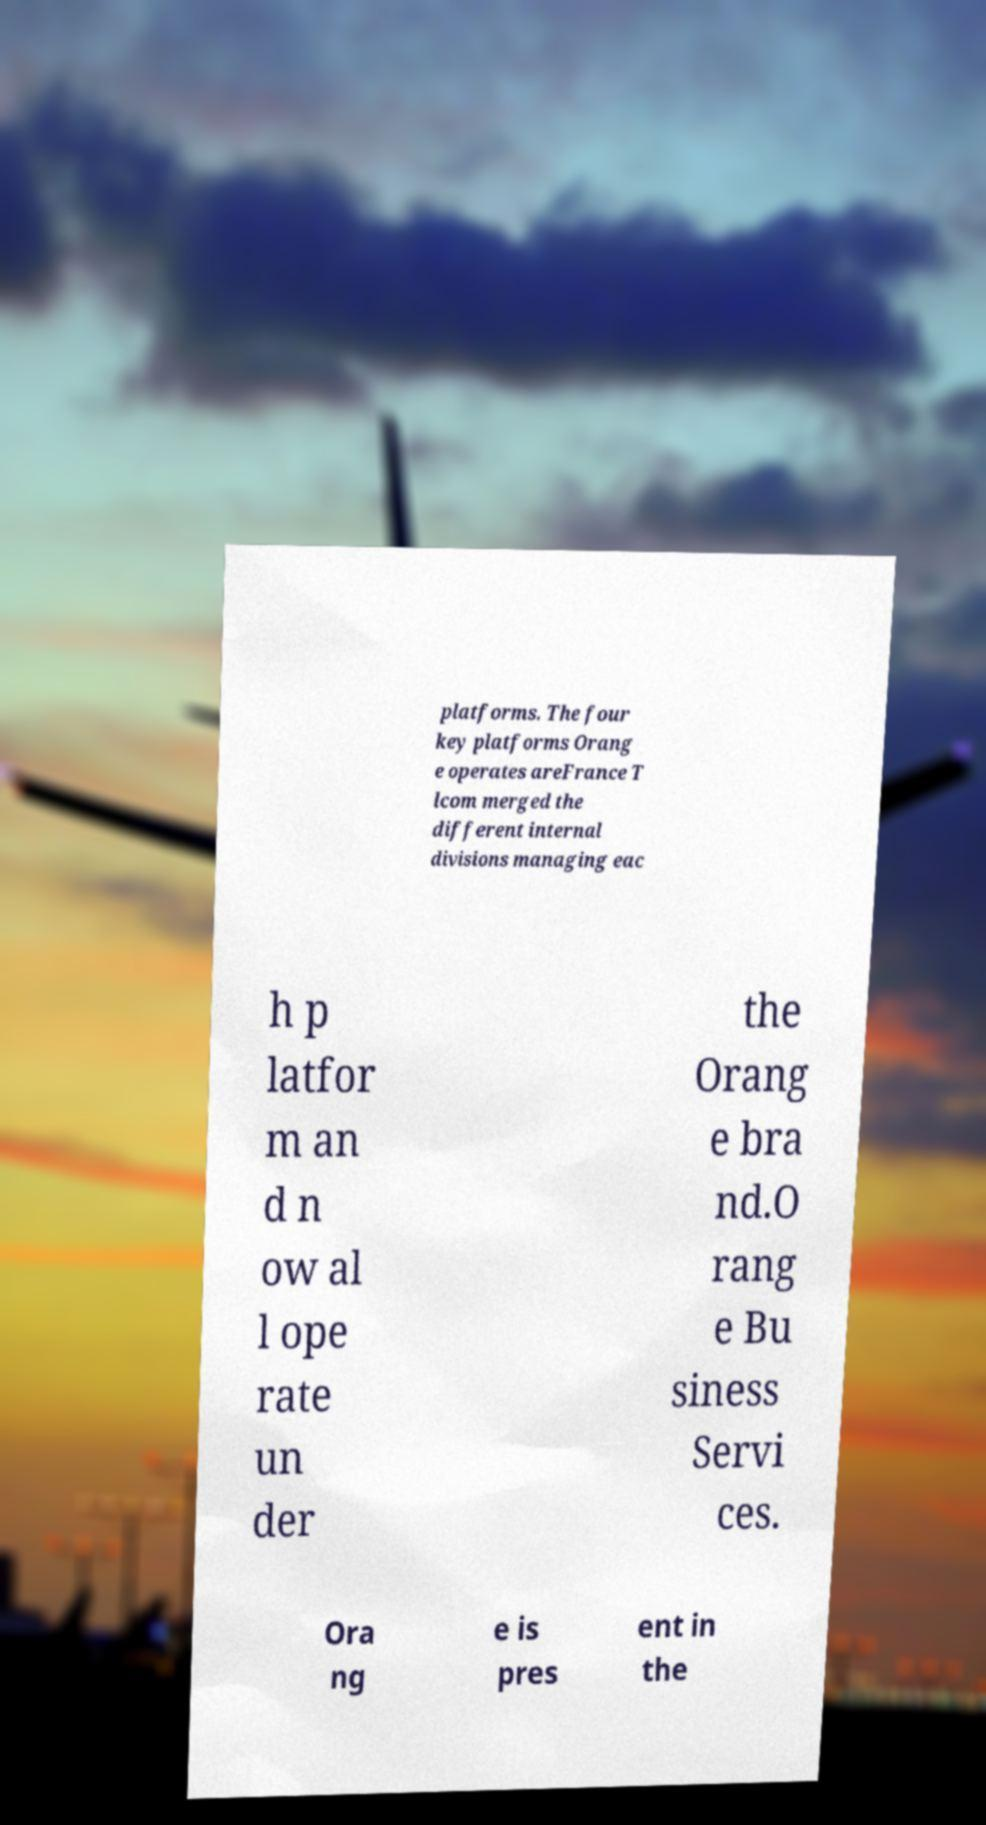Can you read and provide the text displayed in the image?This photo seems to have some interesting text. Can you extract and type it out for me? platforms. The four key platforms Orang e operates areFrance T lcom merged the different internal divisions managing eac h p latfor m an d n ow al l ope rate un der the Orang e bra nd.O rang e Bu siness Servi ces. Ora ng e is pres ent in the 